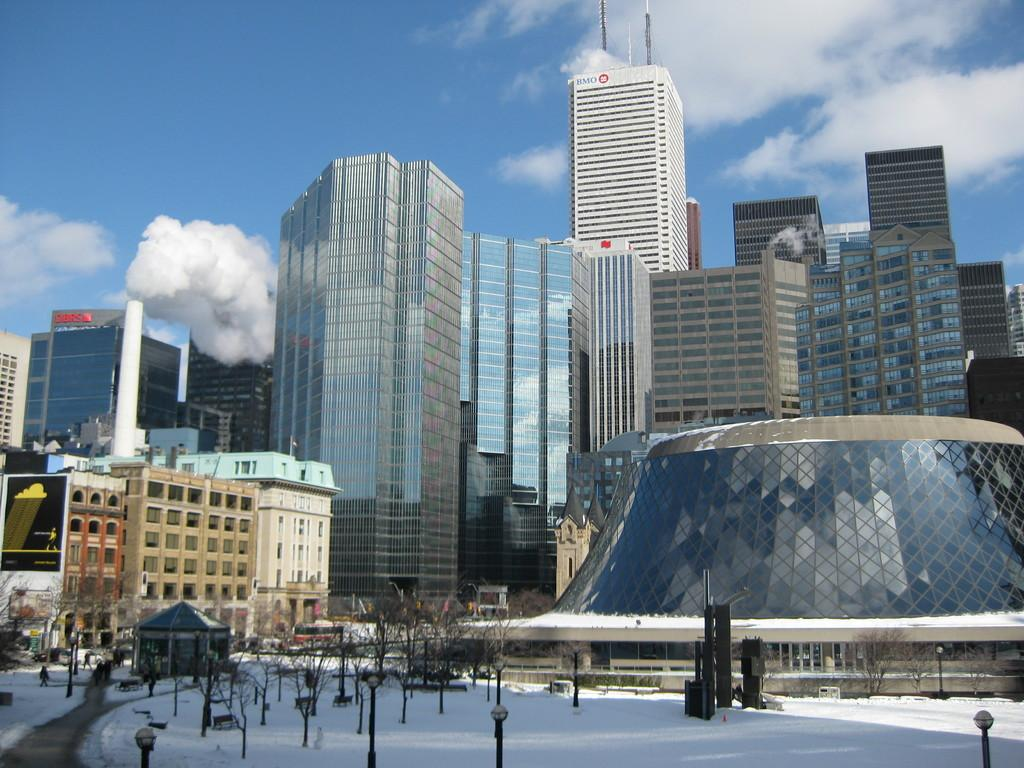What can be seen on the poles in the image? There are lights on poles in the image. What is the condition of the trees in the image? The trees in the image are dried. What is the weather like in the image? There is snow visible in the image, and there are clouds in the sky, indicating a snowy or wintry scene. What can be seen in the background of the image? There are buildings, people, a hoarding, and the sky visible in the background of the image. What type of toothpaste is being advertised on the hoarding in the image? There is no toothpaste or advertisement visible on the hoarding in the image. Can you see a kitty playing with a ball of yarn in the image? There is no kitty or ball of yarn present in the image. 